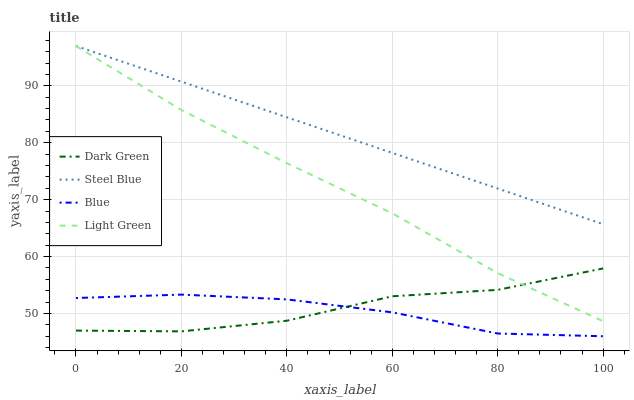Does Blue have the minimum area under the curve?
Answer yes or no. Yes. Does Steel Blue have the maximum area under the curve?
Answer yes or no. Yes. Does Light Green have the minimum area under the curve?
Answer yes or no. No. Does Light Green have the maximum area under the curve?
Answer yes or no. No. Is Steel Blue the smoothest?
Answer yes or no. Yes. Is Dark Green the roughest?
Answer yes or no. Yes. Is Light Green the smoothest?
Answer yes or no. No. Is Light Green the roughest?
Answer yes or no. No. Does Blue have the lowest value?
Answer yes or no. Yes. Does Light Green have the lowest value?
Answer yes or no. No. Does Light Green have the highest value?
Answer yes or no. Yes. Does Dark Green have the highest value?
Answer yes or no. No. Is Blue less than Steel Blue?
Answer yes or no. Yes. Is Steel Blue greater than Dark Green?
Answer yes or no. Yes. Does Steel Blue intersect Light Green?
Answer yes or no. Yes. Is Steel Blue less than Light Green?
Answer yes or no. No. Is Steel Blue greater than Light Green?
Answer yes or no. No. Does Blue intersect Steel Blue?
Answer yes or no. No. 